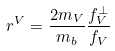Convert formula to latex. <formula><loc_0><loc_0><loc_500><loc_500>r ^ { V } = \frac { 2 m _ { V } } { m _ { b } } \frac { f _ { V } ^ { \perp } } { f _ { V } }</formula> 